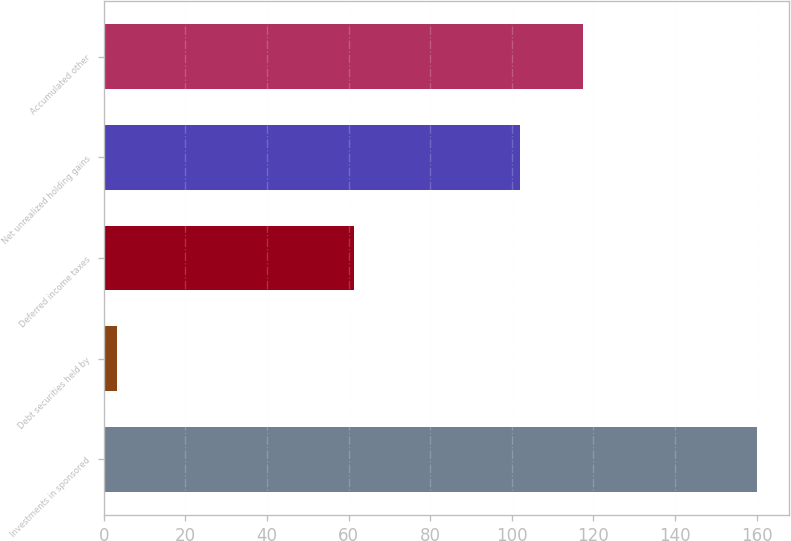<chart> <loc_0><loc_0><loc_500><loc_500><bar_chart><fcel>Investments in sponsored<fcel>Debt securities held by<fcel>Deferred income taxes<fcel>Net unrealized holding gains<fcel>Accumulated other<nl><fcel>160<fcel>3.3<fcel>61.4<fcel>101.9<fcel>117.57<nl></chart> 